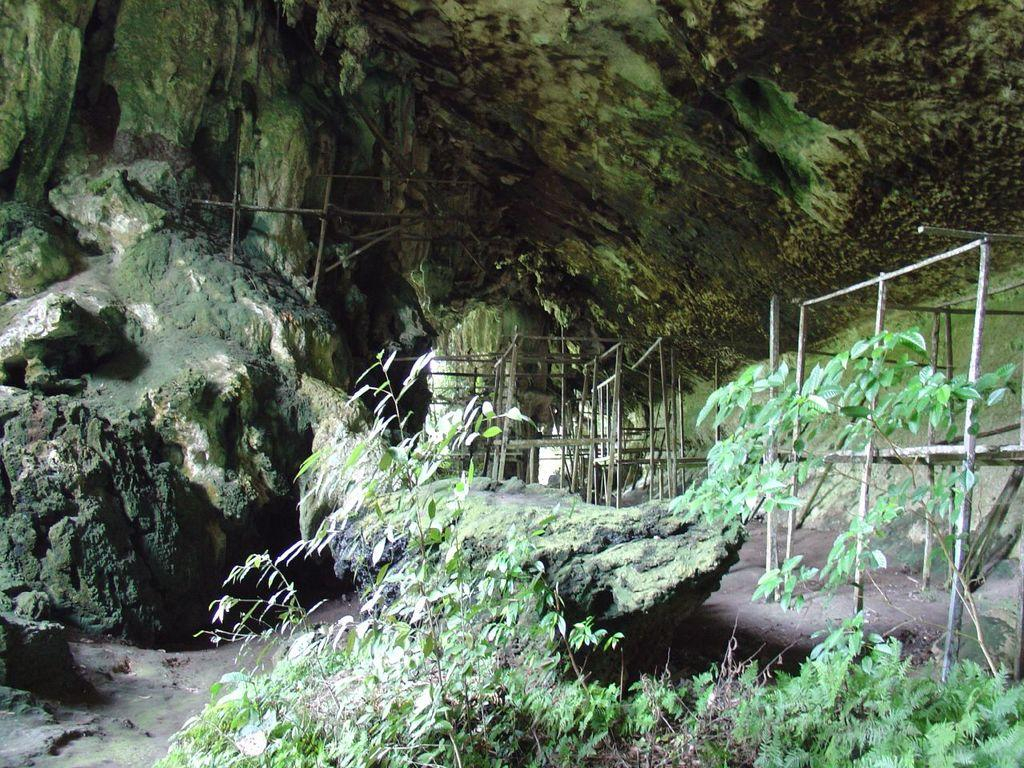What is located in the foreground of the image? There are plants in the foreground of the image. What can be seen in the distance in the image? There are hills visible in the background of the image. What type of structure is depicted in the image? The image appears to depict a tunnel. What type of barrier is present in the image? There are fences present in the image. How many sisters are walking on the sidewalk in the image? There is no sidewalk or sisters present in the image. What color is the hair of the person in the image? There is no person or hair visible in the image. 